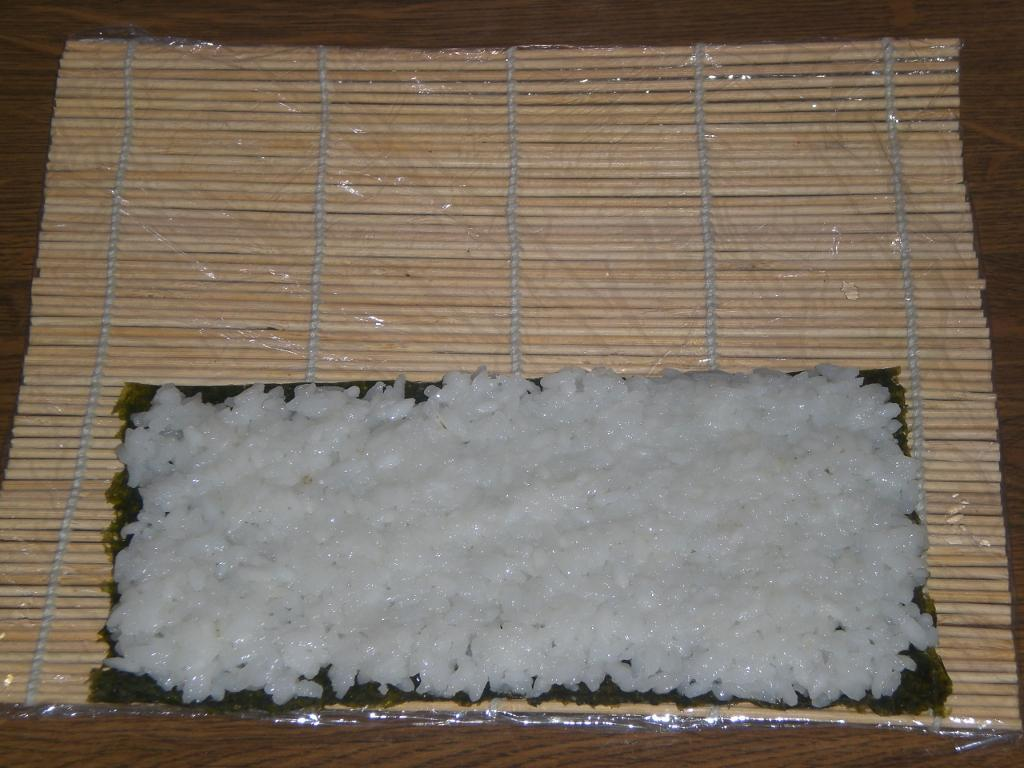What type of food is visible in the image? There is cooked rice in the image. What is the cooked rice placed on? The cooked rice is on a cloth. What type of mat is on the table in the image? There is a wooden sticks mat on the table. Is the wooden sticks mat visible in the image? Yes, the wooden sticks mat is in the image. What route does the cooked rice take to reach the table in the image? The cooked rice does not move or take a route in the image; it is already on the table. 